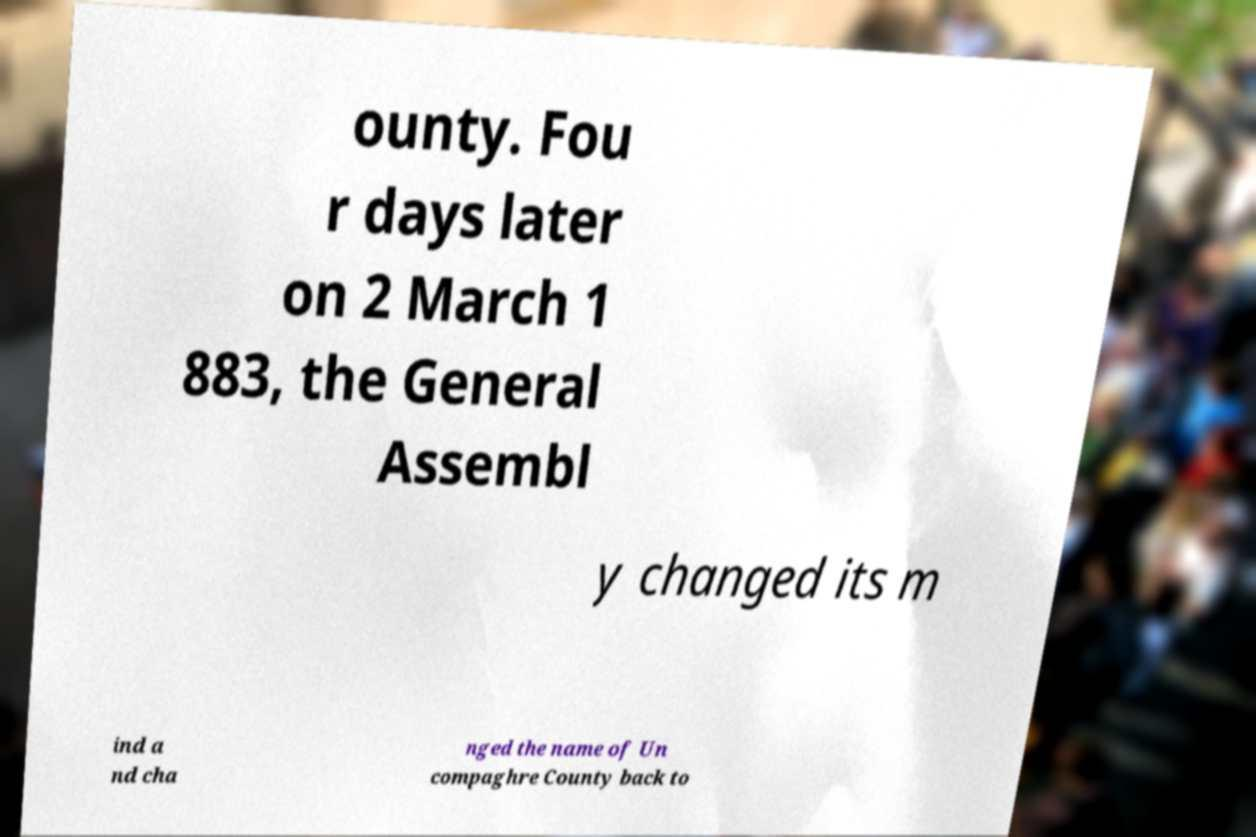Can you accurately transcribe the text from the provided image for me? ounty. Fou r days later on 2 March 1 883, the General Assembl y changed its m ind a nd cha nged the name of Un compaghre County back to 